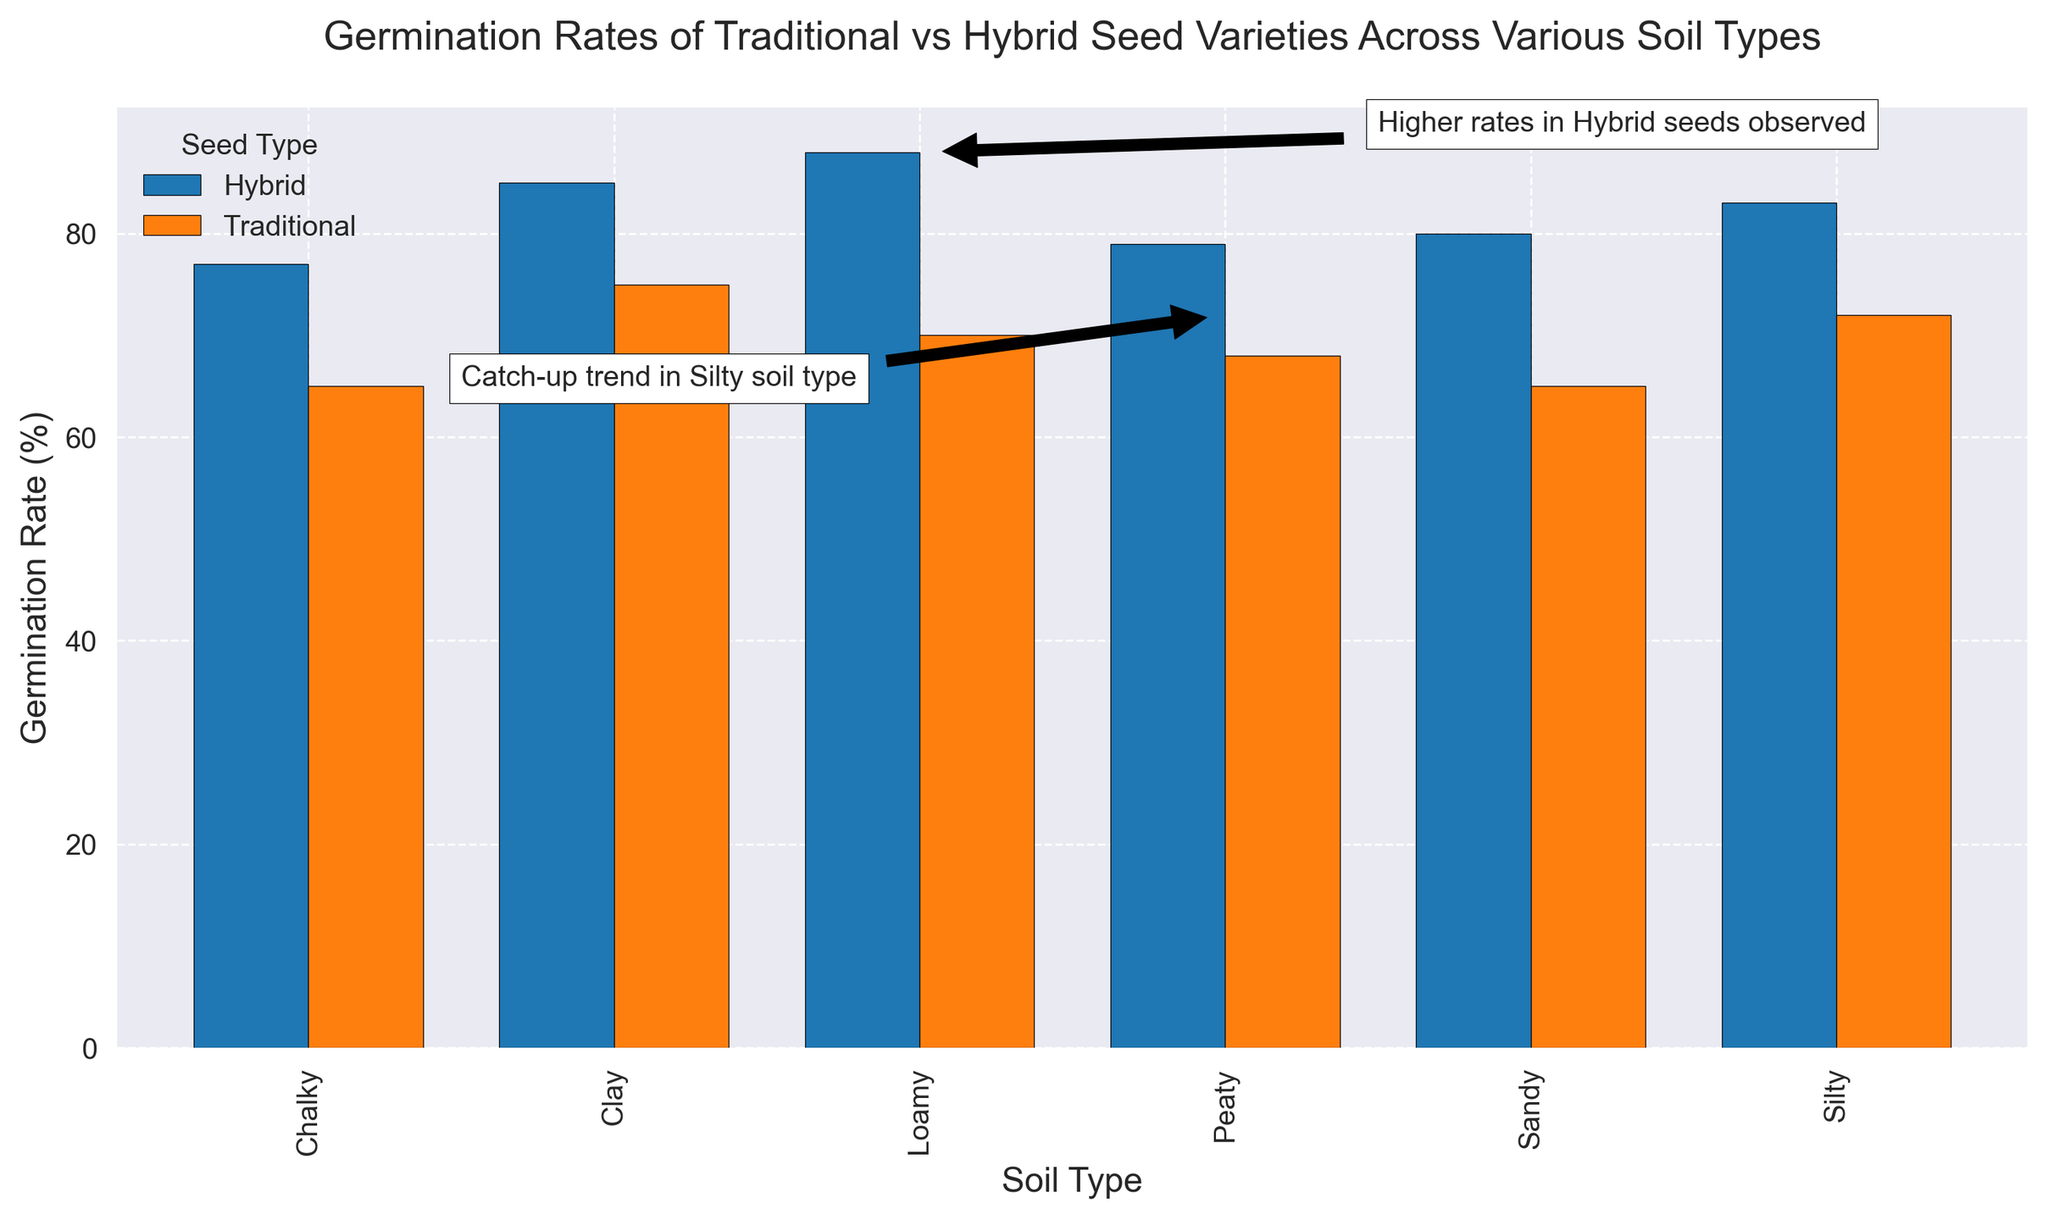What's the germination rate difference between Traditional and Hybrid seeds in Clay soil? Identify the germination rates for Clay soil, which are 75% for Traditional seeds and 85% for Hybrid seeds. Subtract 75 from 85 to find the difference.
Answer: 10% Which soil type shows the highest germination rate for Hybrid seeds? Examine the germination rates for Hybrid seeds across all soil types. The highest value is 88% in Loamy soil.
Answer: Loamy Is there any soil type where Traditional seeds have a higher germination rate than Hybrid seeds? Compare the germination rates of Traditional and Hybrid seeds for each soil type. In all cases, the germination rate for Hybrid seeds is higher than that for Traditional seeds.
Answer: No What is the average germination rate of Traditional seeds across all soil types? Sum the germination rates of Traditional seeds (75 + 65 + 70 + 72 + 68 + 65 = 415) and divide by the number of soil types (6).
Answer: Approximately 69.2% Which soil type shows the smallest difference in germination rates between Traditional and Hybrid seeds? Calculate the differences for each soil type: Clay (10%), Sandy (15%), Loamy (18%), Silty (11%), Peaty (11%), Chalky (12%). The smallest difference is 10% in Clay soil.
Answer: Clay What observation is made about the germination rates in the Silty soil type? There's an annotation that says 'Catch-up trend in Silty soil type.' This suggests a notable observation about the trend in germination rates for this soil type.
Answer: Catch-up trend How do the germination rates for Hybrid seeds in Sandy and Silty soils compare? Identify the germination rates for Hybrid seeds in Sandy (80%) and Silty (83%) soils. Compare the two values.
Answer: Silty is higher Which seed type generally shows better germination rates across the shown soil types? Compare the overall germination rates for Traditional and Hybrid seeds across all soil types. In each soil type, Hybrid seeds have higher rates.
Answer: Hybrid seeds What trend can be seen from the annotation regarding Hybrid seeds? The annotation 'Higher rates in Hybrid seeds observed' indicates that Hybrid seeds generally have better germination rates than Traditional seeds.
Answer: Hybrid seeds have higher rates Which soil type has the lowest germination rate for Traditional seeds? Examine the germination rates for Traditional seeds across all soil types. The lowest rate is 65% in Sandy and Chalky soils.
Answer: Sandy and Chalky 